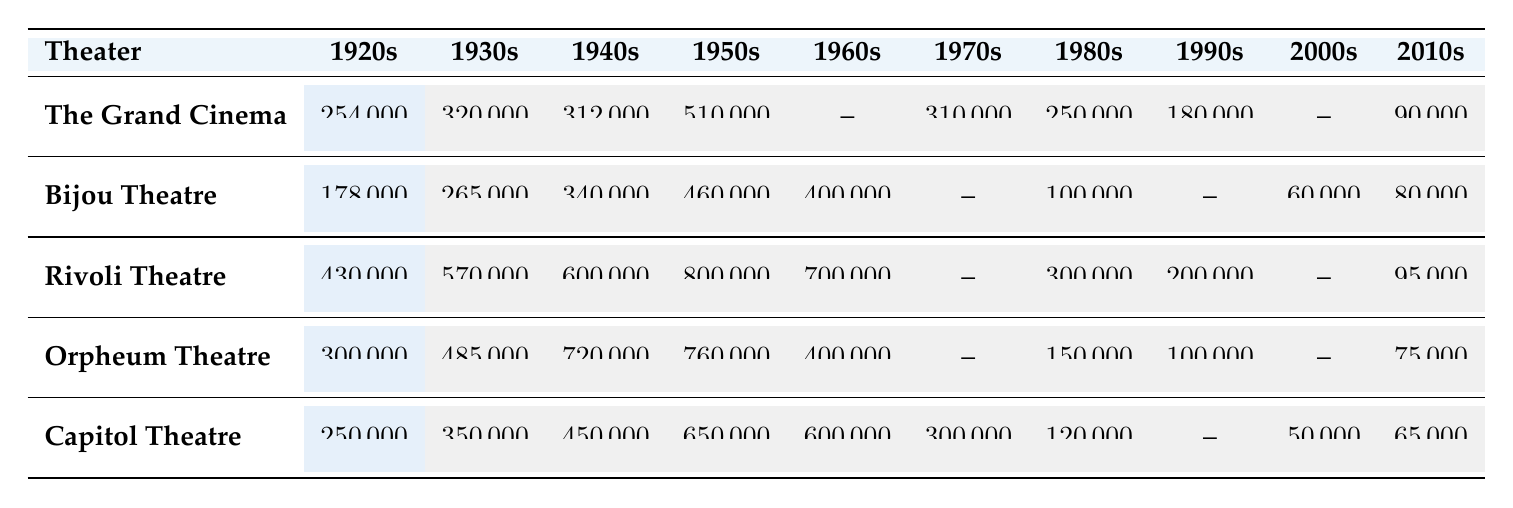What was the highest attendance recorded at any theater in the 1950s? The highest attendance in the 1950s is 800,000 at Rivoli Theatre.
Answer: 800,000 Which theater had null attendance records in the 2000s? The theaters that had null attendance records in the 2000s are The Grand Cinema, Rivoli Theatre, and Orpheum Theatre.
Answer: The Grand Cinema, Rivoli Theatre, Orpheum Theatre Calculate the average attendance for the 1920s across all theaters. Adding the attendance for each theater in the 1920s gives (254,000 + 178,000 + 430,000 + 300,000 + 250,000) = 1,412,000; there are 5 theaters, so the average is 1,412,000 / 5 = 282,400.
Answer: 282,400 Is it true that all theaters had decreasing attendance from the 1950s to the 2010s? Not all theaters had decreasing attendance. For example, Bijou Theatre had 460,000 in the 1950s and rose to 400,000 in the 1960s. Therefore, it did not consistently decrease.
Answer: No What was the attendance drop from the 1950s to the 1960s at the Rivoli Theatre? Rivoli Theatre's attendance was 800,000 in the 1950s and dropped to 700,000 in the 1960s, a decrease of 100,000.
Answer: 100,000 Which theater had the lowest recorded attendance in the 2010s? The lowest attendance in the 2010s was at Orpheum Theatre with 75,000.
Answer: 75,000 How many theaters had attendance records for the 1970s? The only theater with a recorded attendance in the 1970s is Capitol Theatre, which has 300,000. The others have null attendance records.
Answer: 1 What is the total attendance across all theaters in the 1940s? Adding the attendance for the 1940s gives (312,000 + 340,000 + 600,000 + 720,000 + 450,000) = 2,422,000.
Answer: 2,422,000 In which decade did The Grand Cinema experience its highest attendance? The Grand Cinema had its highest attendance in the 1950s with 510,000.
Answer: 1950s Which theater had the highest total attendance over all recorded decades? Calculating the total attendance for each theater reveals that Rivoli Theatre has the highest total with 3,634,000.
Answer: Rivoli Theatre What was the percentage decrease in attendance from the 1920s to the 2010s for Capitol Theatre? The attendance decreased from 250,000 in the 1920s to 65,000 in the 2010s. The decrease is (250,000 - 65,000) = 185,000. The percentage decrease is (185,000 / 250,000) * 100 = 74%.
Answer: 74% 